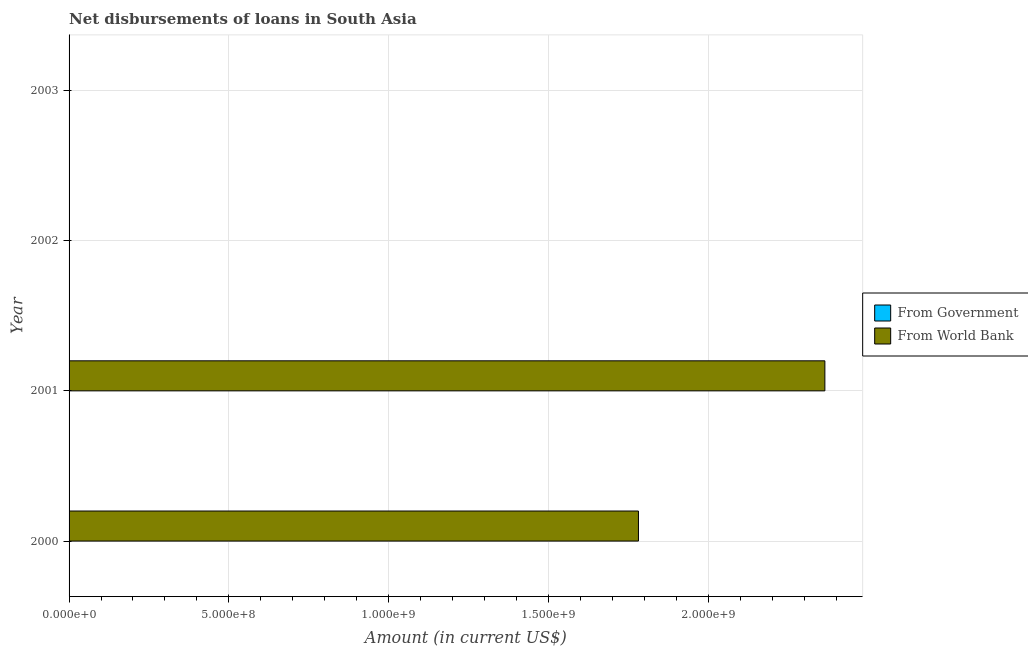How many different coloured bars are there?
Provide a short and direct response. 1. How many bars are there on the 4th tick from the top?
Make the answer very short. 1. What is the net disbursements of loan from world bank in 2000?
Your response must be concise. 1.78e+09. Across all years, what is the maximum net disbursements of loan from world bank?
Your answer should be very brief. 2.37e+09. Across all years, what is the minimum net disbursements of loan from government?
Your answer should be very brief. 0. What is the difference between the net disbursements of loan from world bank in 2000 and that in 2001?
Your answer should be very brief. -5.83e+08. In how many years, is the net disbursements of loan from world bank greater than 2200000000 US$?
Offer a terse response. 1. What is the difference between the highest and the lowest net disbursements of loan from world bank?
Offer a terse response. 2.37e+09. In how many years, is the net disbursements of loan from world bank greater than the average net disbursements of loan from world bank taken over all years?
Offer a very short reply. 2. How many bars are there?
Your answer should be very brief. 2. How many years are there in the graph?
Provide a succinct answer. 4. Are the values on the major ticks of X-axis written in scientific E-notation?
Your answer should be very brief. Yes. Does the graph contain any zero values?
Ensure brevity in your answer.  Yes. What is the title of the graph?
Keep it short and to the point. Net disbursements of loans in South Asia. Does "RDB concessional" appear as one of the legend labels in the graph?
Give a very brief answer. No. What is the label or title of the Y-axis?
Keep it short and to the point. Year. What is the Amount (in current US$) in From World Bank in 2000?
Your response must be concise. 1.78e+09. What is the Amount (in current US$) of From Government in 2001?
Provide a succinct answer. 0. What is the Amount (in current US$) in From World Bank in 2001?
Your response must be concise. 2.37e+09. What is the Amount (in current US$) of From Government in 2002?
Offer a terse response. 0. Across all years, what is the maximum Amount (in current US$) in From World Bank?
Your response must be concise. 2.37e+09. What is the total Amount (in current US$) in From World Bank in the graph?
Ensure brevity in your answer.  4.15e+09. What is the difference between the Amount (in current US$) in From World Bank in 2000 and that in 2001?
Your answer should be compact. -5.83e+08. What is the average Amount (in current US$) in From Government per year?
Provide a short and direct response. 0. What is the average Amount (in current US$) in From World Bank per year?
Provide a short and direct response. 1.04e+09. What is the ratio of the Amount (in current US$) of From World Bank in 2000 to that in 2001?
Make the answer very short. 0.75. What is the difference between the highest and the lowest Amount (in current US$) in From World Bank?
Offer a terse response. 2.37e+09. 